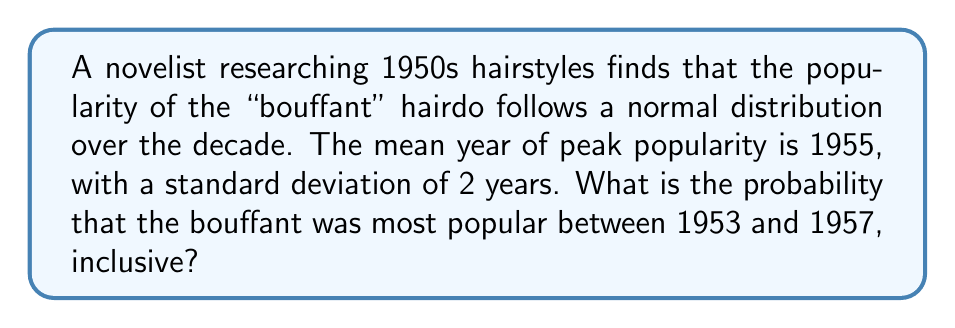Solve this math problem. To solve this problem, we need to use the properties of the normal distribution and the z-score formula.

Step 1: Identify the given information
- The distribution is normal
- Mean (μ) = 1955
- Standard deviation (σ) = 2 years
- We want to find the probability between 1953 and 1957, inclusive

Step 2: Calculate the z-scores for the boundaries
Lower bound: z₁ = (1953 - 1955) / 2 = -1
Upper bound: z₂ = (1957 - 1955) / 2 = 1

Step 3: Find the area under the standard normal curve between z₁ and z₂
We need to find P(-1 ≤ Z ≤ 1)

This can be calculated as:
P(-1 ≤ Z ≤ 1) = P(Z ≤ 1) - P(Z ≤ -1)

Using a standard normal distribution table or calculator:
P(Z ≤ 1) ≈ 0.8413
P(Z ≤ -1) ≈ 0.1587

Step 4: Calculate the final probability
P(-1 ≤ Z ≤ 1) = 0.8413 - 0.1587 = 0.6826

Therefore, the probability that the bouffant was most popular between 1953 and 1957, inclusive, is approximately 0.6826 or 68.26%.
Answer: 0.6826 or 68.26% 